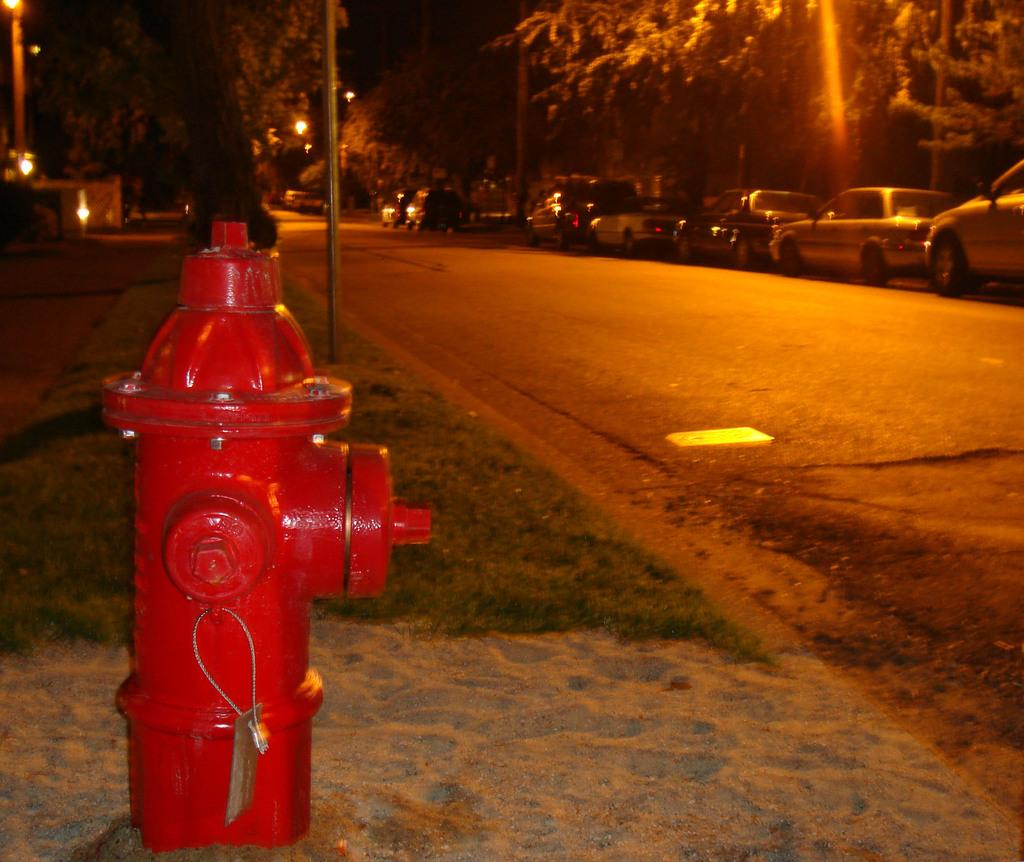What object can be found on the road in the image? There is a fire hydrant on the road in the image. What type of vehicles are present in the image? There are cars in the image. What natural elements can be seen in the image? There are trees in the image. What type of fowl can be seen singing in harmony in the image? There is no fowl or any indication of singing or harmony present in the image. What type of glass object is visible in the image? There is no glass object present in the image. 